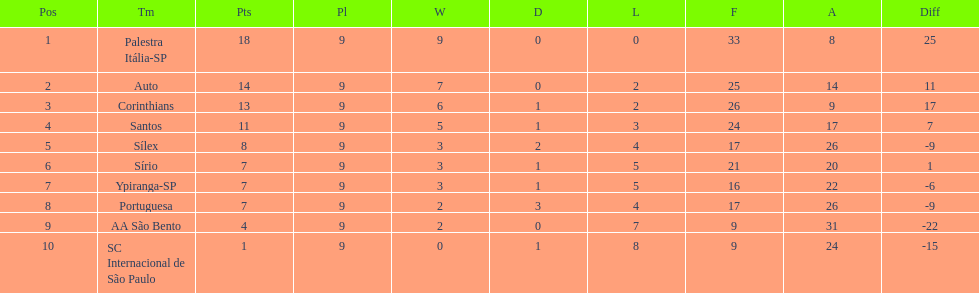How many points did the brazilian football team auto get in 1926? 14. Could you parse the entire table as a dict? {'header': ['Pos', 'Tm', 'Pts', 'Pl', 'W', 'D', 'L', 'F', 'A', 'Diff'], 'rows': [['1', 'Palestra Itália-SP', '18', '9', '9', '0', '0', '33', '8', '25'], ['2', 'Auto', '14', '9', '7', '0', '2', '25', '14', '11'], ['3', 'Corinthians', '13', '9', '6', '1', '2', '26', '9', '17'], ['4', 'Santos', '11', '9', '5', '1', '3', '24', '17', '7'], ['5', 'Sílex', '8', '9', '3', '2', '4', '17', '26', '-9'], ['6', 'Sírio', '7', '9', '3', '1', '5', '21', '20', '1'], ['7', 'Ypiranga-SP', '7', '9', '3', '1', '5', '16', '22', '-6'], ['8', 'Portuguesa', '7', '9', '2', '3', '4', '17', '26', '-9'], ['9', 'AA São Bento', '4', '9', '2', '0', '7', '9', '31', '-22'], ['10', 'SC Internacional de São Paulo', '1', '9', '0', '1', '8', '9', '24', '-15']]} 